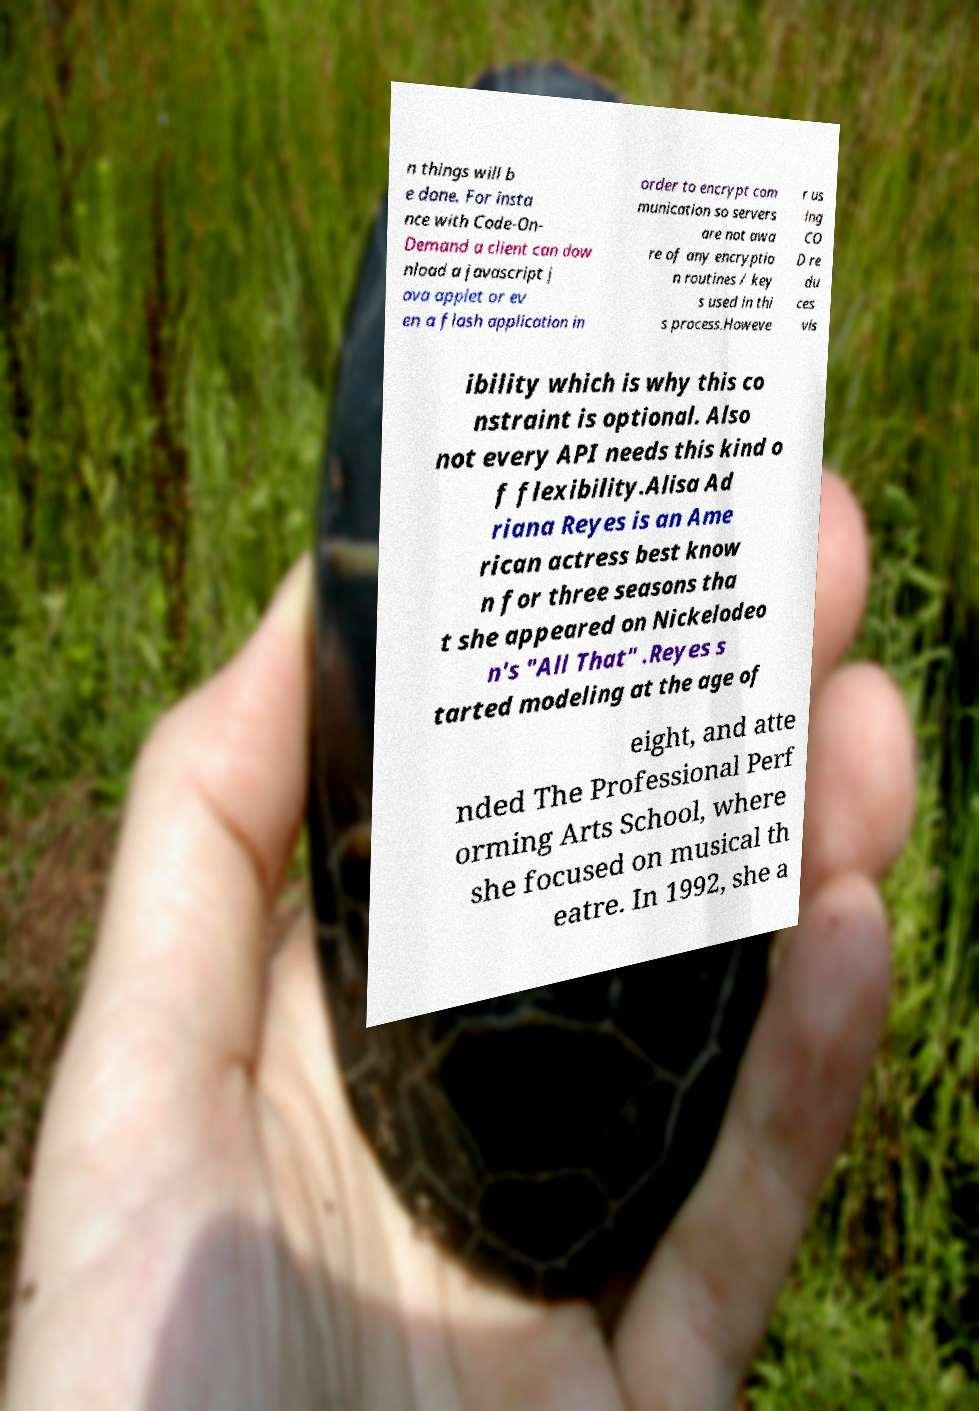Please read and relay the text visible in this image. What does it say? n things will b e done. For insta nce with Code-On- Demand a client can dow nload a javascript j ava applet or ev en a flash application in order to encrypt com munication so servers are not awa re of any encryptio n routines / key s used in thi s process.Howeve r us ing CO D re du ces vis ibility which is why this co nstraint is optional. Also not every API needs this kind o f flexibility.Alisa Ad riana Reyes is an Ame rican actress best know n for three seasons tha t she appeared on Nickelodeo n's "All That" .Reyes s tarted modeling at the age of eight, and atte nded The Professional Perf orming Arts School, where she focused on musical th eatre. In 1992, she a 